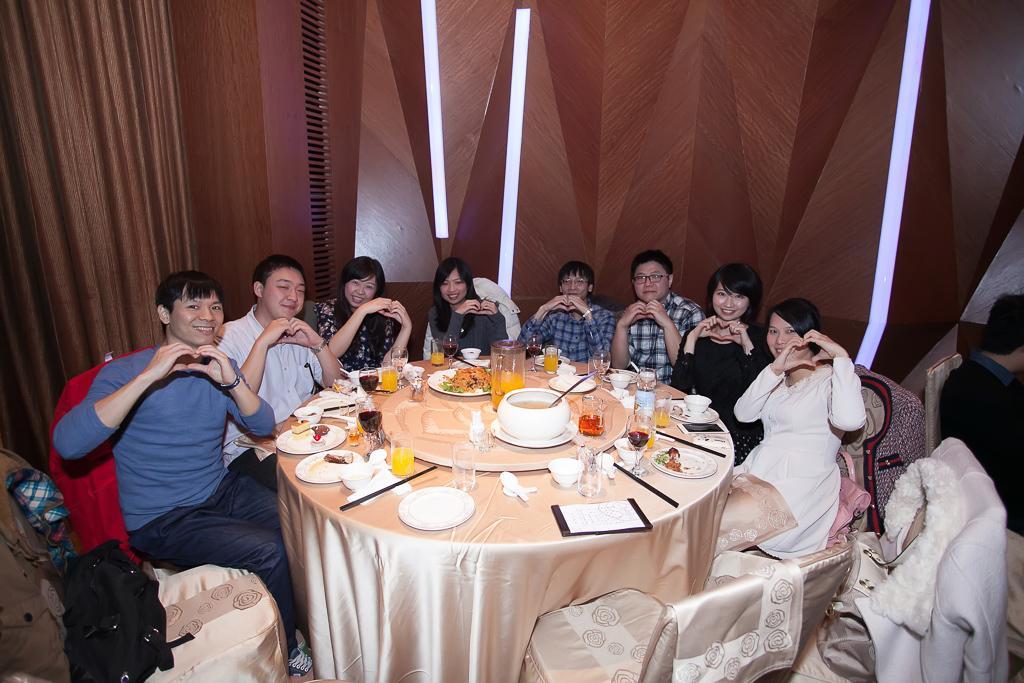Describe this image in one or two sentences. In this image there are group of people sitting on chair surrounded by a table. Person at the left side is wearing blue shirt. Woman at the right side is wearing white dress. On the table there is a bowl , jar, glasses, plates, chopsticks are there. At the right side there is a person sitting on the chair. 